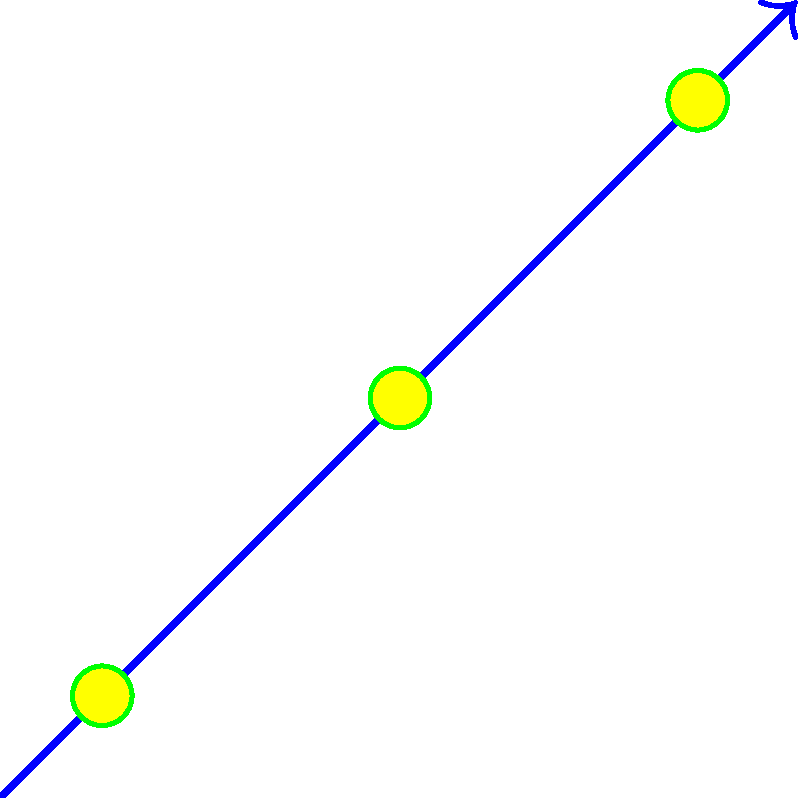Given the wind direction and flower placement shown in the diagram, which area is most likely to have the highest concentration of pollen particles? How might this affect the placement of guests at an outdoor wedding to minimize allergy risks? To answer this question, we need to analyze the diagram and understand the factors affecting pollen distribution:

1. Wind direction: The blue arrow indicates the wind is blowing from the bottom-left to the top-right (approximately 45 degrees).

2. Flower placement: There are three yellow flowers located at different points on the graph.

3. Pollen dispersion: The red dots represent pollen particles dispersed from each flower.

4. Pollen concentration: Areas with a higher density of red dots indicate a higher concentration of pollen particles.

Analyzing these factors:

1. The wind carries pollen particles predominantly in the direction it's blowing (top-right).

2. Pollen from all three flowers is being carried in this general direction.

3. The area with the highest concentration of pollen will be where the dispersal patterns from multiple flowers overlap.

4. This overlap occurs most prominently in the top-right quadrant of the diagram.

To minimize allergy risks at an outdoor wedding:

1. Avoid placing guests in the top-right quadrant of the area.

2. Position seating areas and the ceremony location in the bottom-left quadrant, upwind of the flowers.

3. If possible, remove or relocate flowers that contribute significantly to the high-concentration area.

4. Consider using hypoallergenic or low-pollen producing flowers for decorations.

5. Plan the wedding for a time of day when pollen counts are typically lower (often early morning or late evening).
Answer: Top-right quadrant; place guests in bottom-left, upwind area 